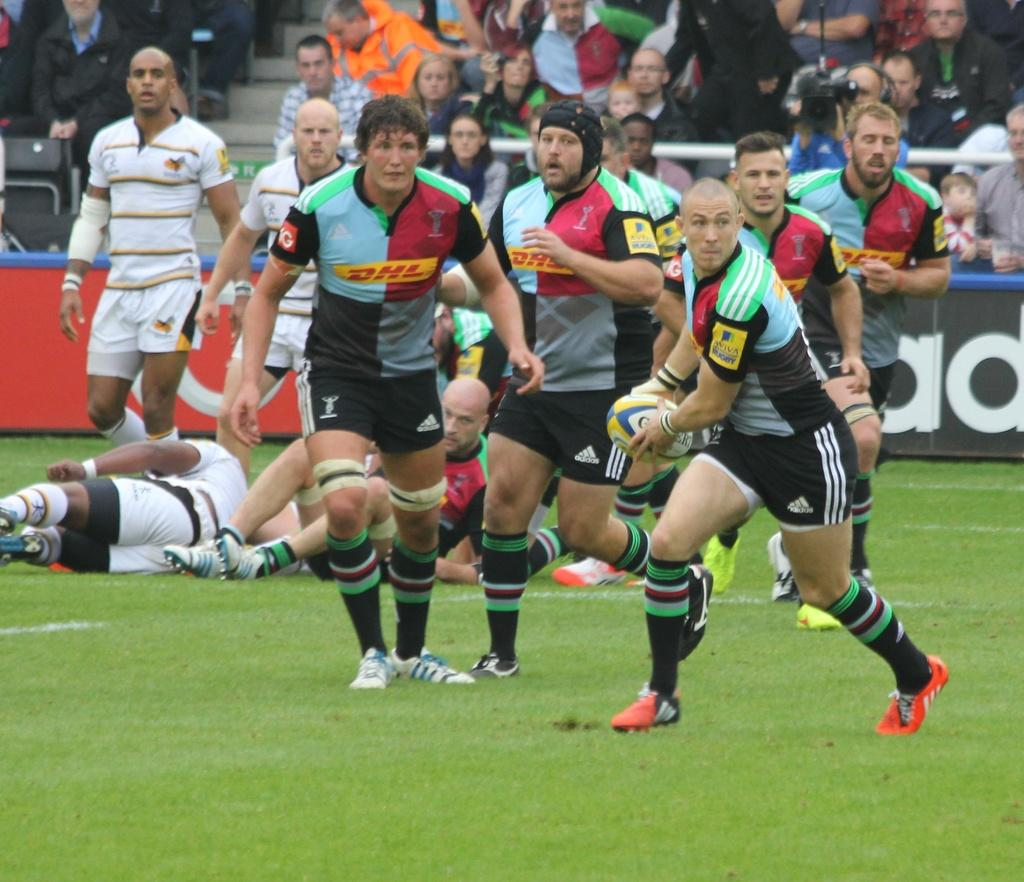What are the men in the image doing on the grass? Some men are standing, while others are lying on the grass. Can you describe the position of the men in the image? The men are either standing or lying on the grass. What can be seen in the background of the image? There are people visible in the background of the image. Where is the mom sitting with her cup in the image? There is no mom or cup present in the image. 